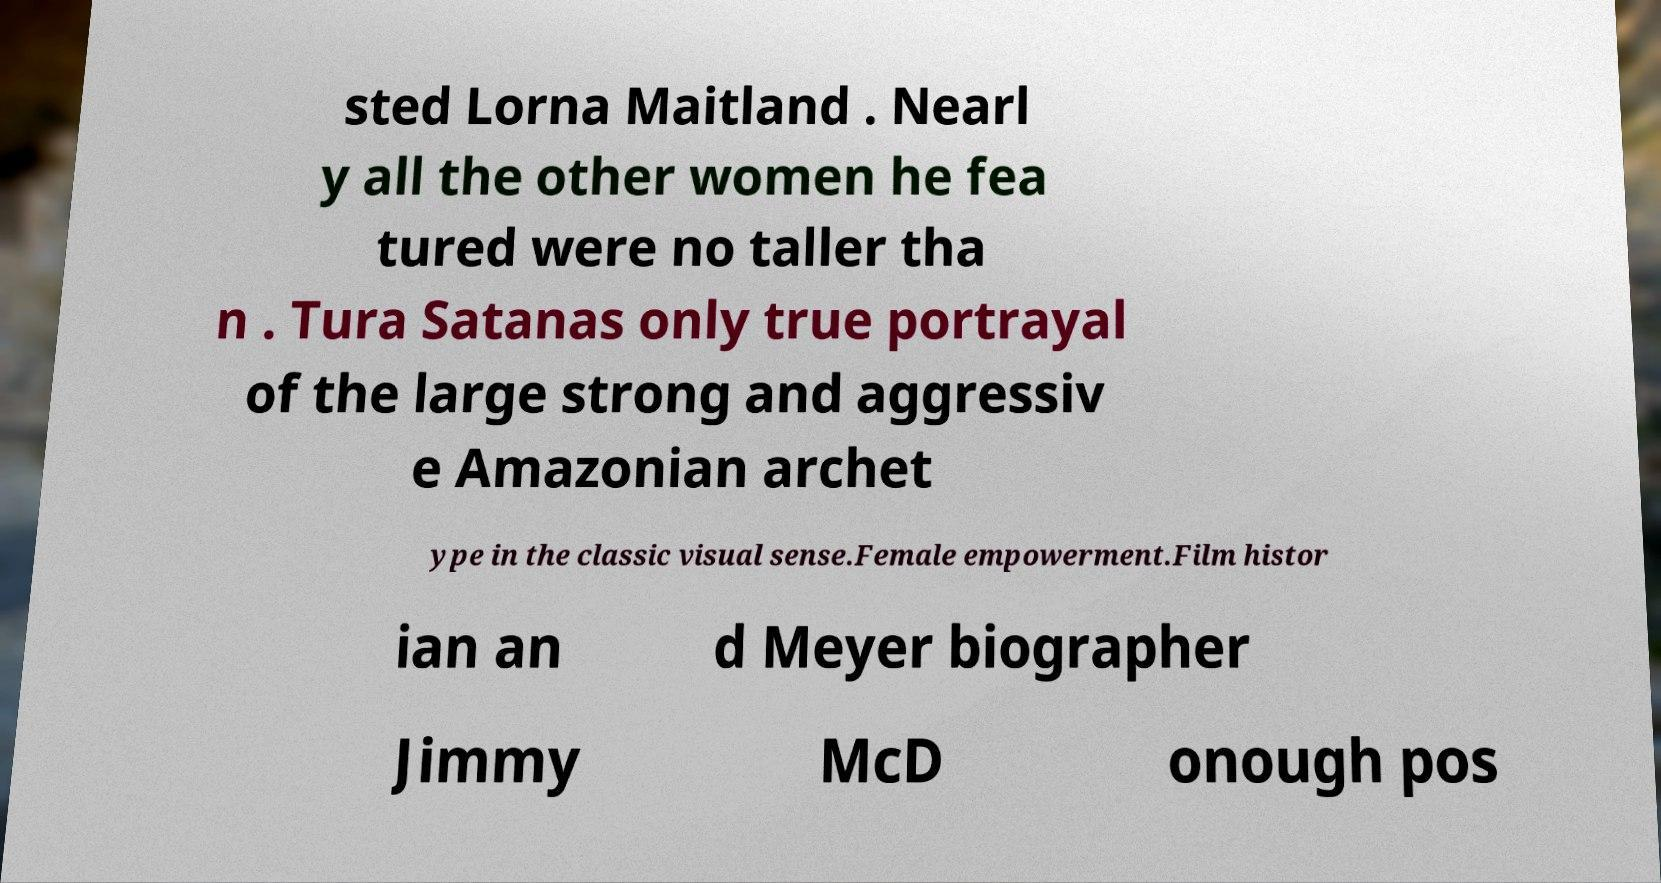Can you read and provide the text displayed in the image?This photo seems to have some interesting text. Can you extract and type it out for me? sted Lorna Maitland . Nearl y all the other women he fea tured were no taller tha n . Tura Satanas only true portrayal of the large strong and aggressiv e Amazonian archet ype in the classic visual sense.Female empowerment.Film histor ian an d Meyer biographer Jimmy McD onough pos 